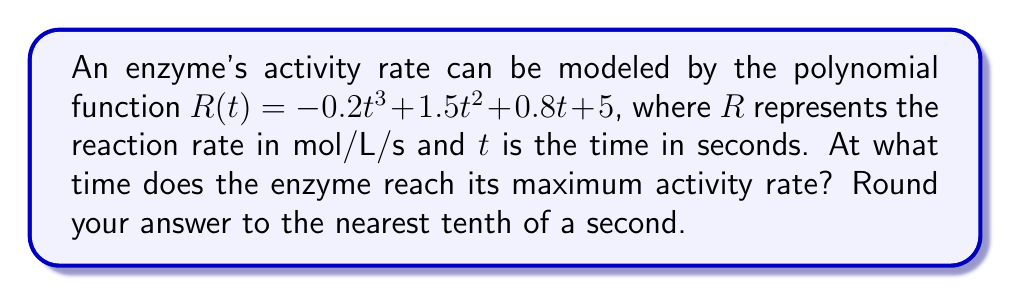Can you solve this math problem? To find the maximum activity rate, we need to determine when the derivative of $R(t)$ equals zero.

1) First, let's find the derivative of $R(t)$:
   $$R'(t) = -0.6t^2 + 3t + 0.8$$

2) Set $R'(t) = 0$ and solve for $t$:
   $$-0.6t^2 + 3t + 0.8 = 0$$

3) This is a quadratic equation. We can solve it using the quadratic formula:
   $$t = \frac{-b \pm \sqrt{b^2 - 4ac}}{2a}$$
   where $a = -0.6$, $b = 3$, and $c = 0.8$

4) Substituting these values:
   $$t = \frac{-3 \pm \sqrt{3^2 - 4(-0.6)(0.8)}}{2(-0.6)}$$
   $$t = \frac{-3 \pm \sqrt{9 + 1.92}}{-1.2}$$
   $$t = \frac{-3 \pm \sqrt{10.92}}{-1.2}$$
   $$t = \frac{-3 \pm 3.305}{-1.2}$$

5) This gives us two solutions:
   $$t_1 = \frac{-3 + 3.305}{-1.2} \approx 0.254$$
   $$t_2 = \frac{-3 - 3.305}{-1.2} \approx 5.254$$

6) To determine which solution gives the maximum (rather than minimum) rate, we can check the second derivative:
   $$R''(t) = -1.2t + 3$$

   At $t = 0.254$, $R''(0.254) = 2.695 > 0$, indicating a minimum.
   At $t = 5.254$, $R''(5.254) = -3.305 < 0$, indicating a maximum.

Therefore, the maximum activity rate occurs at $t \approx 5.3$ seconds (rounded to the nearest tenth).
Answer: 5.3 seconds 